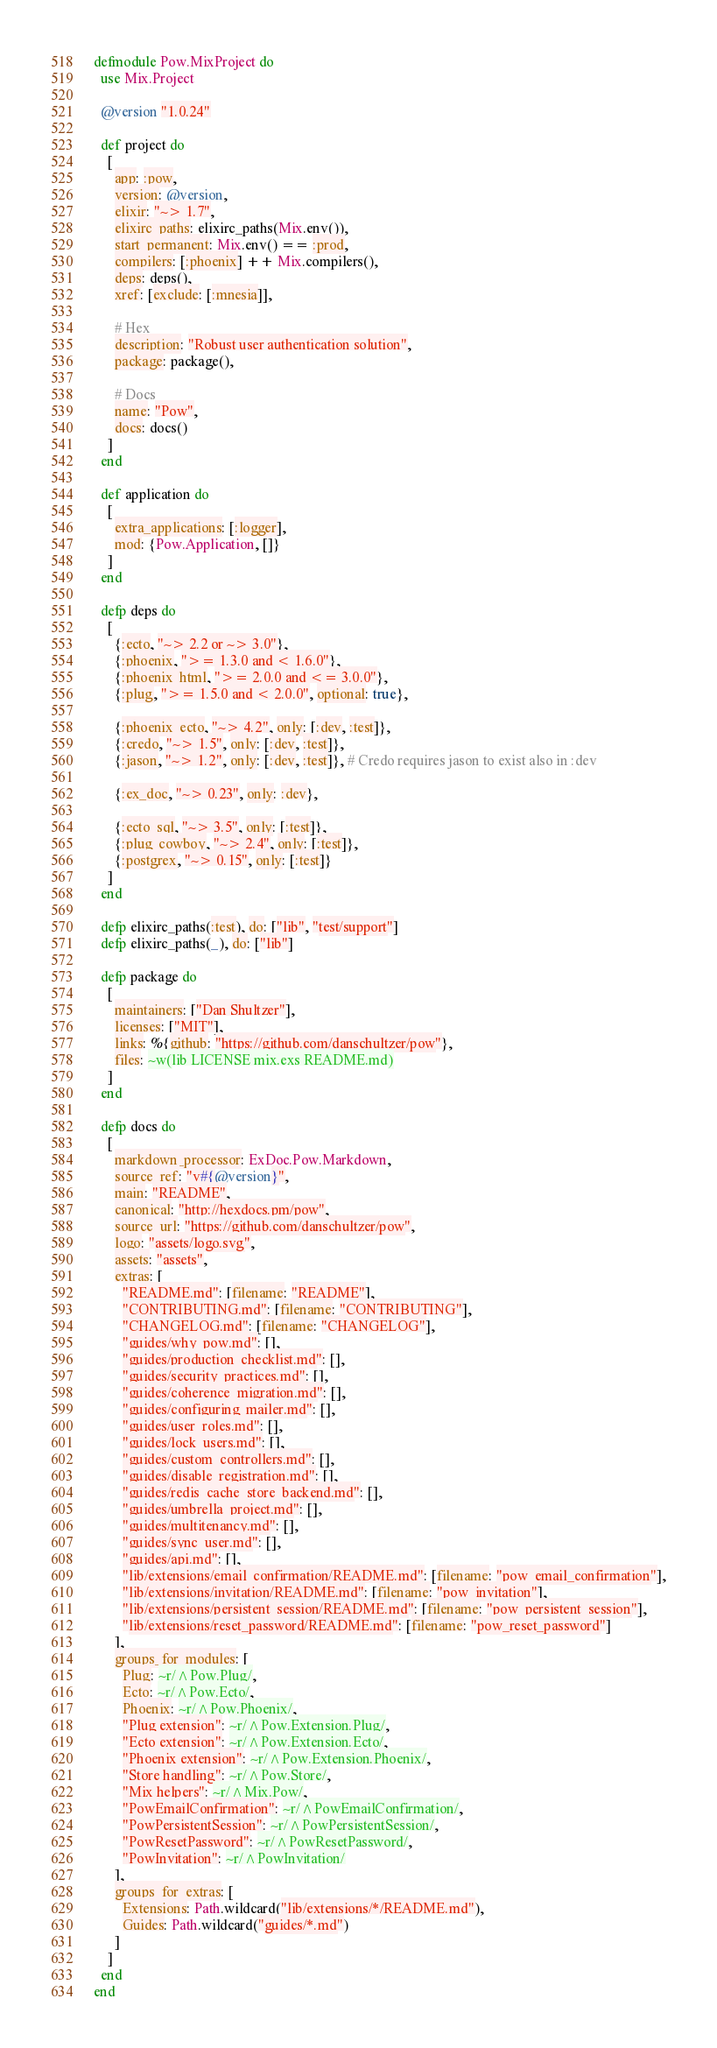Convert code to text. <code><loc_0><loc_0><loc_500><loc_500><_Elixir_>defmodule Pow.MixProject do
  use Mix.Project

  @version "1.0.24"

  def project do
    [
      app: :pow,
      version: @version,
      elixir: "~> 1.7",
      elixirc_paths: elixirc_paths(Mix.env()),
      start_permanent: Mix.env() == :prod,
      compilers: [:phoenix] ++ Mix.compilers(),
      deps: deps(),
      xref: [exclude: [:mnesia]],

      # Hex
      description: "Robust user authentication solution",
      package: package(),

      # Docs
      name: "Pow",
      docs: docs()
    ]
  end

  def application do
    [
      extra_applications: [:logger],
      mod: {Pow.Application, []}
    ]
  end

  defp deps do
    [
      {:ecto, "~> 2.2 or ~> 3.0"},
      {:phoenix, ">= 1.3.0 and < 1.6.0"},
      {:phoenix_html, ">= 2.0.0 and <= 3.0.0"},
      {:plug, ">= 1.5.0 and < 2.0.0", optional: true},

      {:phoenix_ecto, "~> 4.2", only: [:dev, :test]},
      {:credo, "~> 1.5", only: [:dev, :test]},
      {:jason, "~> 1.2", only: [:dev, :test]}, # Credo requires jason to exist also in :dev

      {:ex_doc, "~> 0.23", only: :dev},

      {:ecto_sql, "~> 3.5", only: [:test]},
      {:plug_cowboy, "~> 2.4", only: [:test]},
      {:postgrex, "~> 0.15", only: [:test]}
    ]
  end

  defp elixirc_paths(:test), do: ["lib", "test/support"]
  defp elixirc_paths(_), do: ["lib"]

  defp package do
    [
      maintainers: ["Dan Shultzer"],
      licenses: ["MIT"],
      links: %{github: "https://github.com/danschultzer/pow"},
      files: ~w(lib LICENSE mix.exs README.md)
    ]
  end

  defp docs do
    [
      markdown_processor: ExDoc.Pow.Markdown,
      source_ref: "v#{@version}",
      main: "README",
      canonical: "http://hexdocs.pm/pow",
      source_url: "https://github.com/danschultzer/pow",
      logo: "assets/logo.svg",
      assets: "assets",
      extras: [
        "README.md": [filename: "README"],
        "CONTRIBUTING.md": [filename: "CONTRIBUTING"],
        "CHANGELOG.md": [filename: "CHANGELOG"],
        "guides/why_pow.md": [],
        "guides/production_checklist.md": [],
        "guides/security_practices.md": [],
        "guides/coherence_migration.md": [],
        "guides/configuring_mailer.md": [],
        "guides/user_roles.md": [],
        "guides/lock_users.md": [],
        "guides/custom_controllers.md": [],
        "guides/disable_registration.md": [],
        "guides/redis_cache_store_backend.md": [],
        "guides/umbrella_project.md": [],
        "guides/multitenancy.md": [],
        "guides/sync_user.md": [],
        "guides/api.md": [],
        "lib/extensions/email_confirmation/README.md": [filename: "pow_email_confirmation"],
        "lib/extensions/invitation/README.md": [filename: "pow_invitation"],
        "lib/extensions/persistent_session/README.md": [filename: "pow_persistent_session"],
        "lib/extensions/reset_password/README.md": [filename: "pow_reset_password"]
      ],
      groups_for_modules: [
        Plug: ~r/^Pow.Plug/,
        Ecto: ~r/^Pow.Ecto/,
        Phoenix: ~r/^Pow.Phoenix/,
        "Plug extension": ~r/^Pow.Extension.Plug/,
        "Ecto extension": ~r/^Pow.Extension.Ecto/,
        "Phoenix extension": ~r/^Pow.Extension.Phoenix/,
        "Store handling": ~r/^Pow.Store/,
        "Mix helpers": ~r/^Mix.Pow/,
        "PowEmailConfirmation": ~r/^PowEmailConfirmation/,
        "PowPersistentSession": ~r/^PowPersistentSession/,
        "PowResetPassword": ~r/^PowResetPassword/,
        "PowInvitation": ~r/^PowInvitation/
      ],
      groups_for_extras: [
        Extensions: Path.wildcard("lib/extensions/*/README.md"),
        Guides: Path.wildcard("guides/*.md")
      ]
    ]
  end
end
</code> 